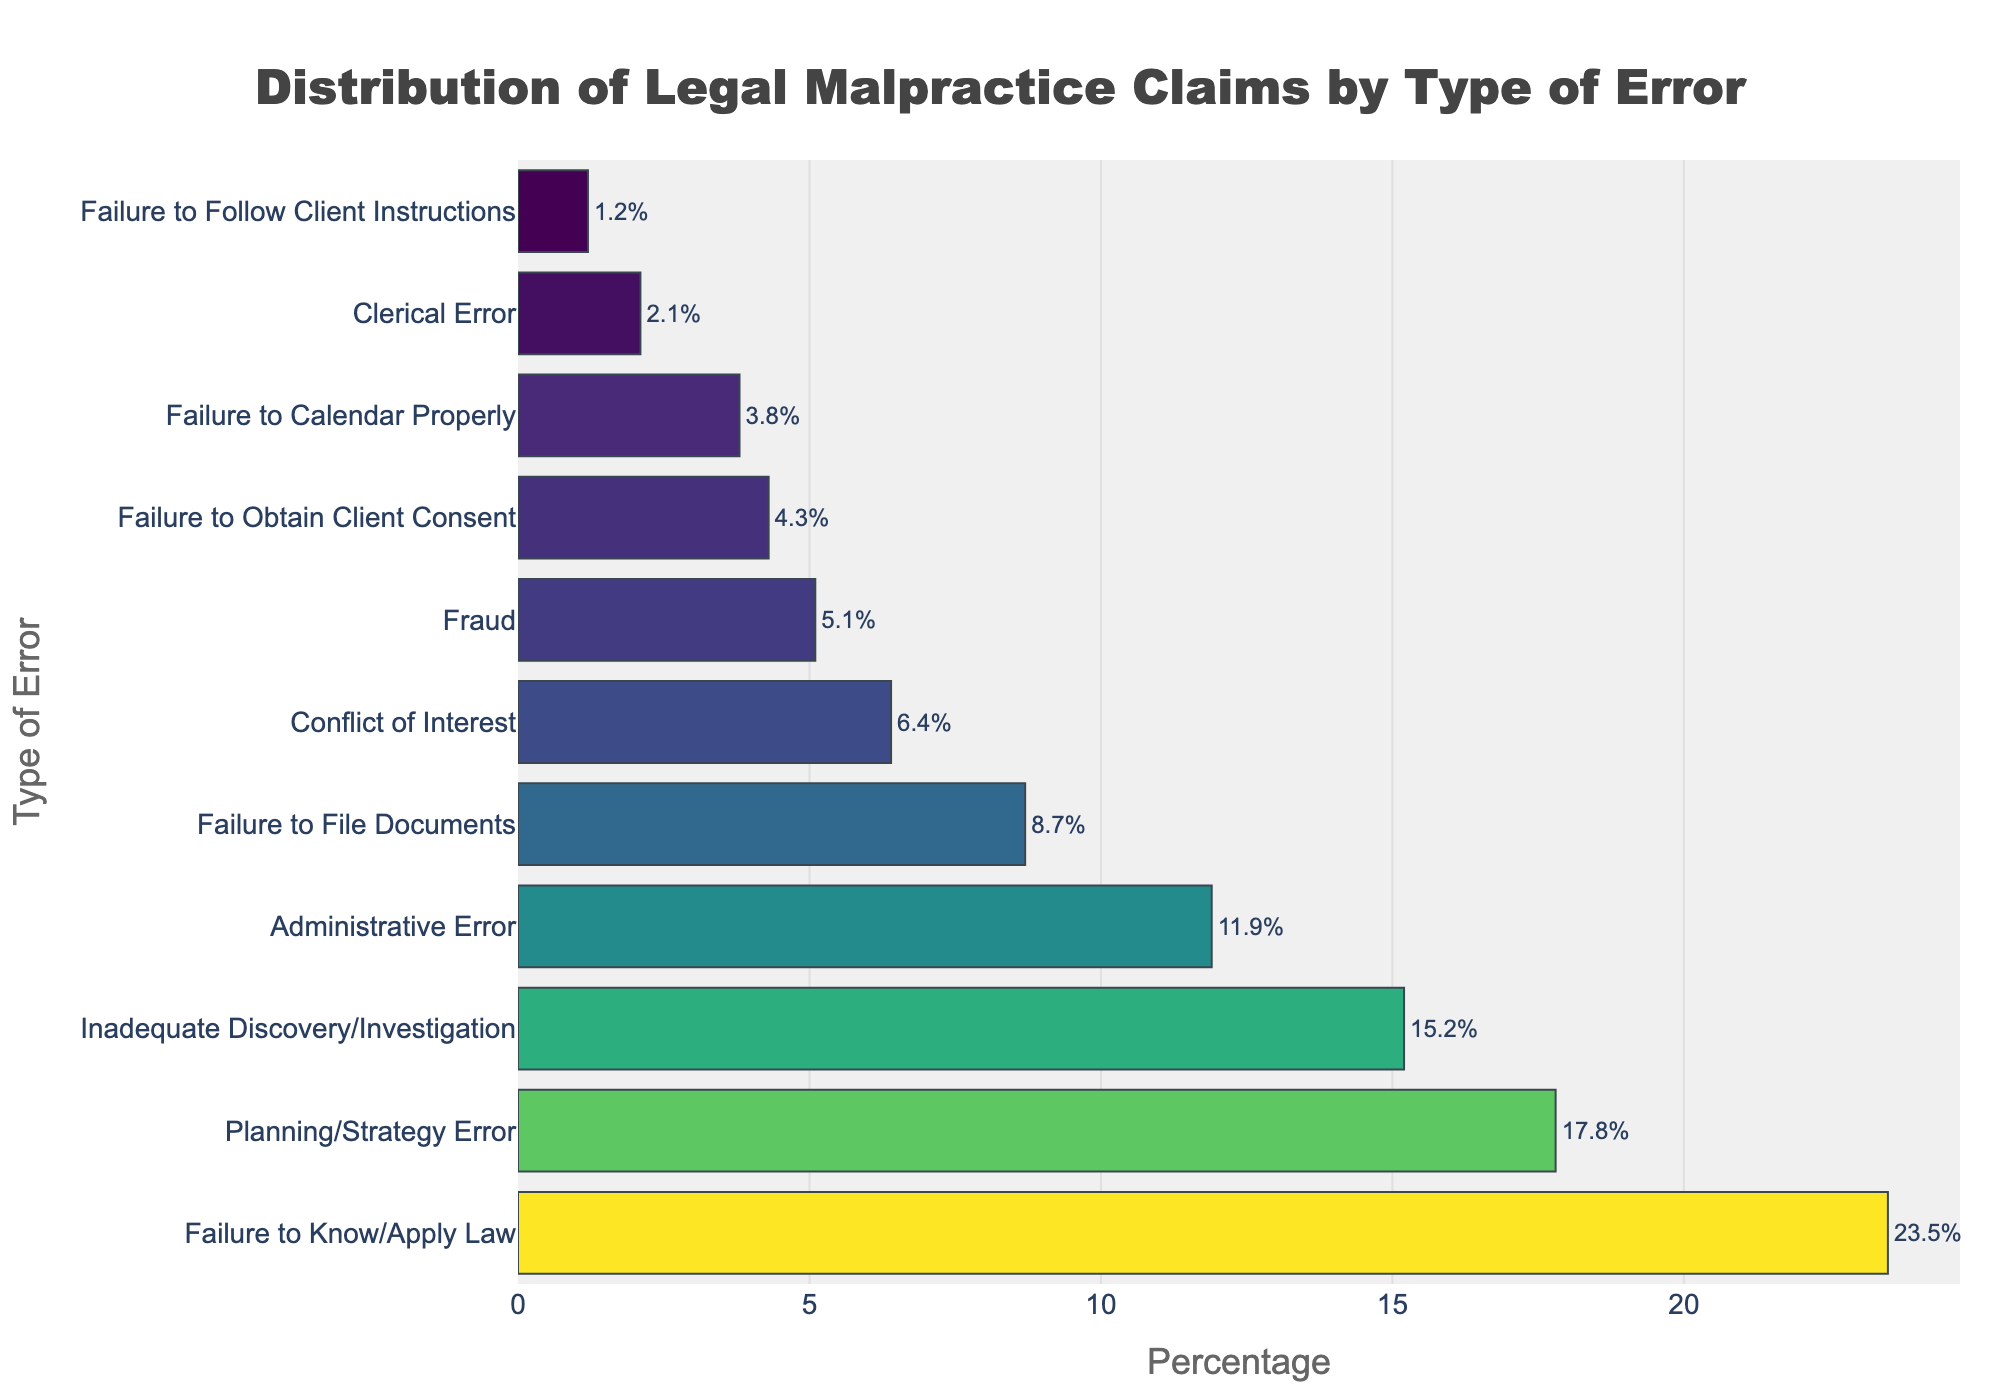What type of error has the highest percentage of legal malpractice claims? The bar with the highest percentage represents the type of error with the highest legal malpractice claims. From the chart, it is "Failure to Know/Apply Law" with 23.5%.
Answer: Failure to Know/Apply Law Which type of error has a lower percentage of claims than "Planning/Strategy Error" but higher than "Administrative Error"? First, identify the percentages for "Planning/Strategy Error" (17.8%) and "Administrative Error" (11.9%). Then, find a type of error with a percentage in between these two values, which is "Inadequate Discovery/Investigation" at 15.2%.
Answer: Inadequate Discovery/Investigation How much higher is the percentage of claims for "Failure to Know/Apply Law" compared to "Failure to Calendar Properly"? "Failure to Know/Apply Law" has 23.5%, and "Failure to Calendar Properly" has 3.8%. Subtract 3.8% from 23.5% to find the difference, which is 19.7%.
Answer: 19.7% List all types of errors with a percentage of claims greater than 10%. Identify bars with percentages greater than 10%. These are: "Failure to Know/Apply Law" (23.5%), "Planning/Strategy Error" (17.8%), "Inadequate Discovery/Investigation" (15.2%), and "Administrative Error" (11.9%).
Answer: Failure to Know/Apply Law, Planning/Strategy Error, Inadequate Discovery/Investigation, Administrative Error What is the combined percentage of claims for "Fraud" and "Conflict of Interest"? Add the percentages for "Fraud" (5.1%) and "Conflict of Interest" (6.4%) together. The combined percentage is 5.1 + 6.4 = 11.5%.
Answer: 11.5% Which type of error has the smallest percentage of legal malpractice claims? Look for the bar with the smallest value, which represents "Failure to Follow Client Instructions" at 1.2%.
Answer: Failure to Follow Client Instructions How does the percentage of "Failure to File Documents" compare to that of "Fraud"? Compare their percentages: "Failure to File Documents" has 8.7%, while "Fraud" has 5.1%. "Failure to File Documents" has a higher percentage.
Answer: Failure to File Documents has a higher percentage What type of error is represented by the fifth longest bar? Count the bars from the longest to the shortest. The fifth longest bar represents "Failure to File Documents" with 8.7%.
Answer: Failure to File Documents If the "Conflict of Interest" percentage was doubled, would it surpass "Planning/Strategy Error"? Doubling "Conflict of Interest" percentage (6.4%) results in 6.4 x 2 = 12.8%. Compare this with "Planning/Strategy Error" (17.8%). 12.8% is less than 17.8%, so it would not surpass it.
Answer: No What is the average percentage of claims for the top three types of errors? The top three types of errors are "Failure to Know/Apply Law" (23.5%), "Planning/Strategy Error" (17.8%), and "Inadequate Discovery/Investigation" (15.2%). Sum these percentages (23.5 + 17.8 + 15.2 = 56.5%) and divide by 3. The average is 56.5 / 3 = 18.83%.
Answer: 18.83% 